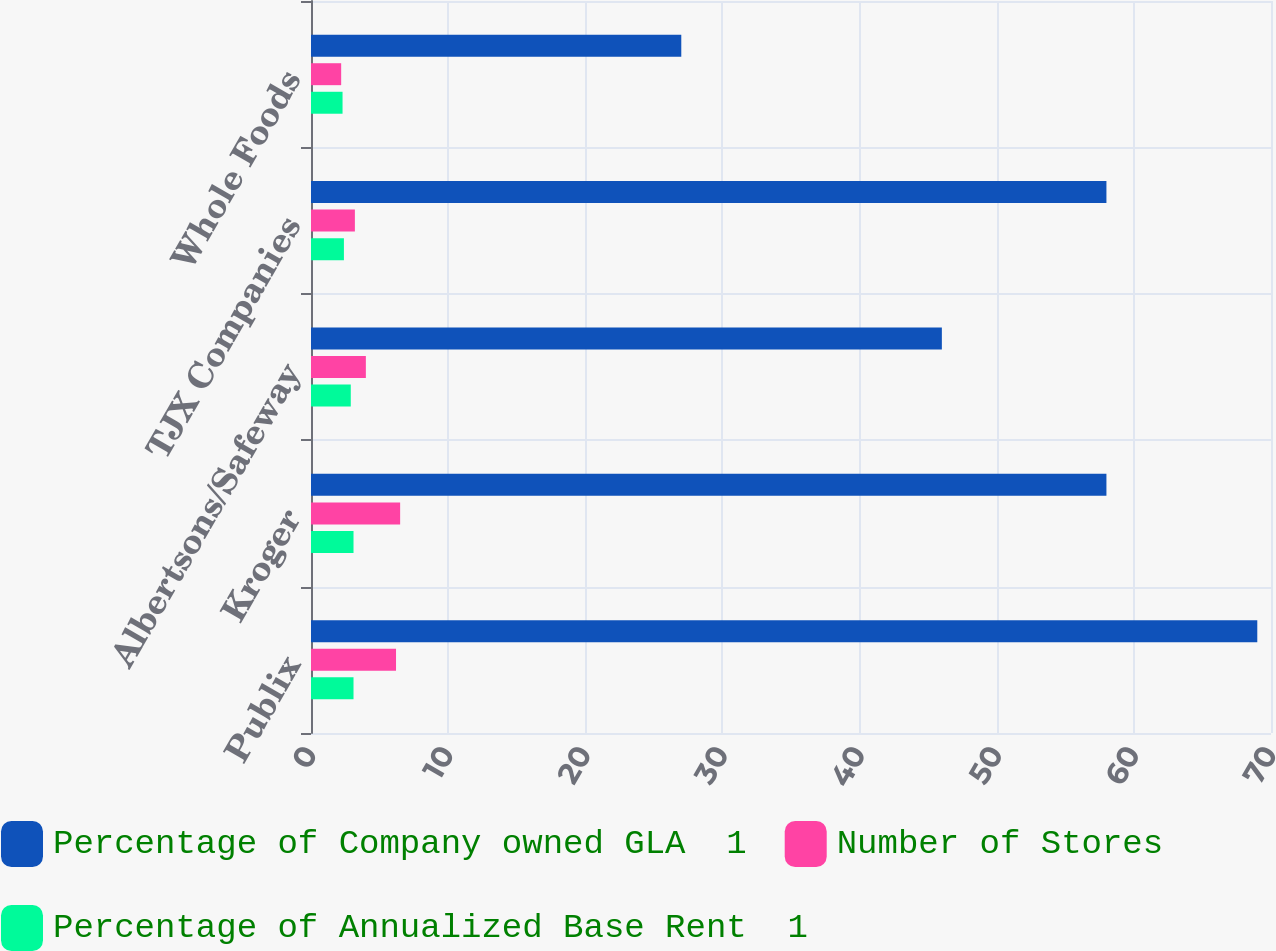Convert chart. <chart><loc_0><loc_0><loc_500><loc_500><stacked_bar_chart><ecel><fcel>Publix<fcel>Kroger<fcel>Albertsons/Safeway<fcel>TJX Companies<fcel>Whole Foods<nl><fcel>Percentage of Company owned GLA  1<fcel>69<fcel>58<fcel>46<fcel>58<fcel>27<nl><fcel>Number of Stores<fcel>6.2<fcel>6.5<fcel>4<fcel>3.2<fcel>2.2<nl><fcel>Percentage of Annualized Base Rent  1<fcel>3.1<fcel>3.1<fcel>2.9<fcel>2.4<fcel>2.3<nl></chart> 